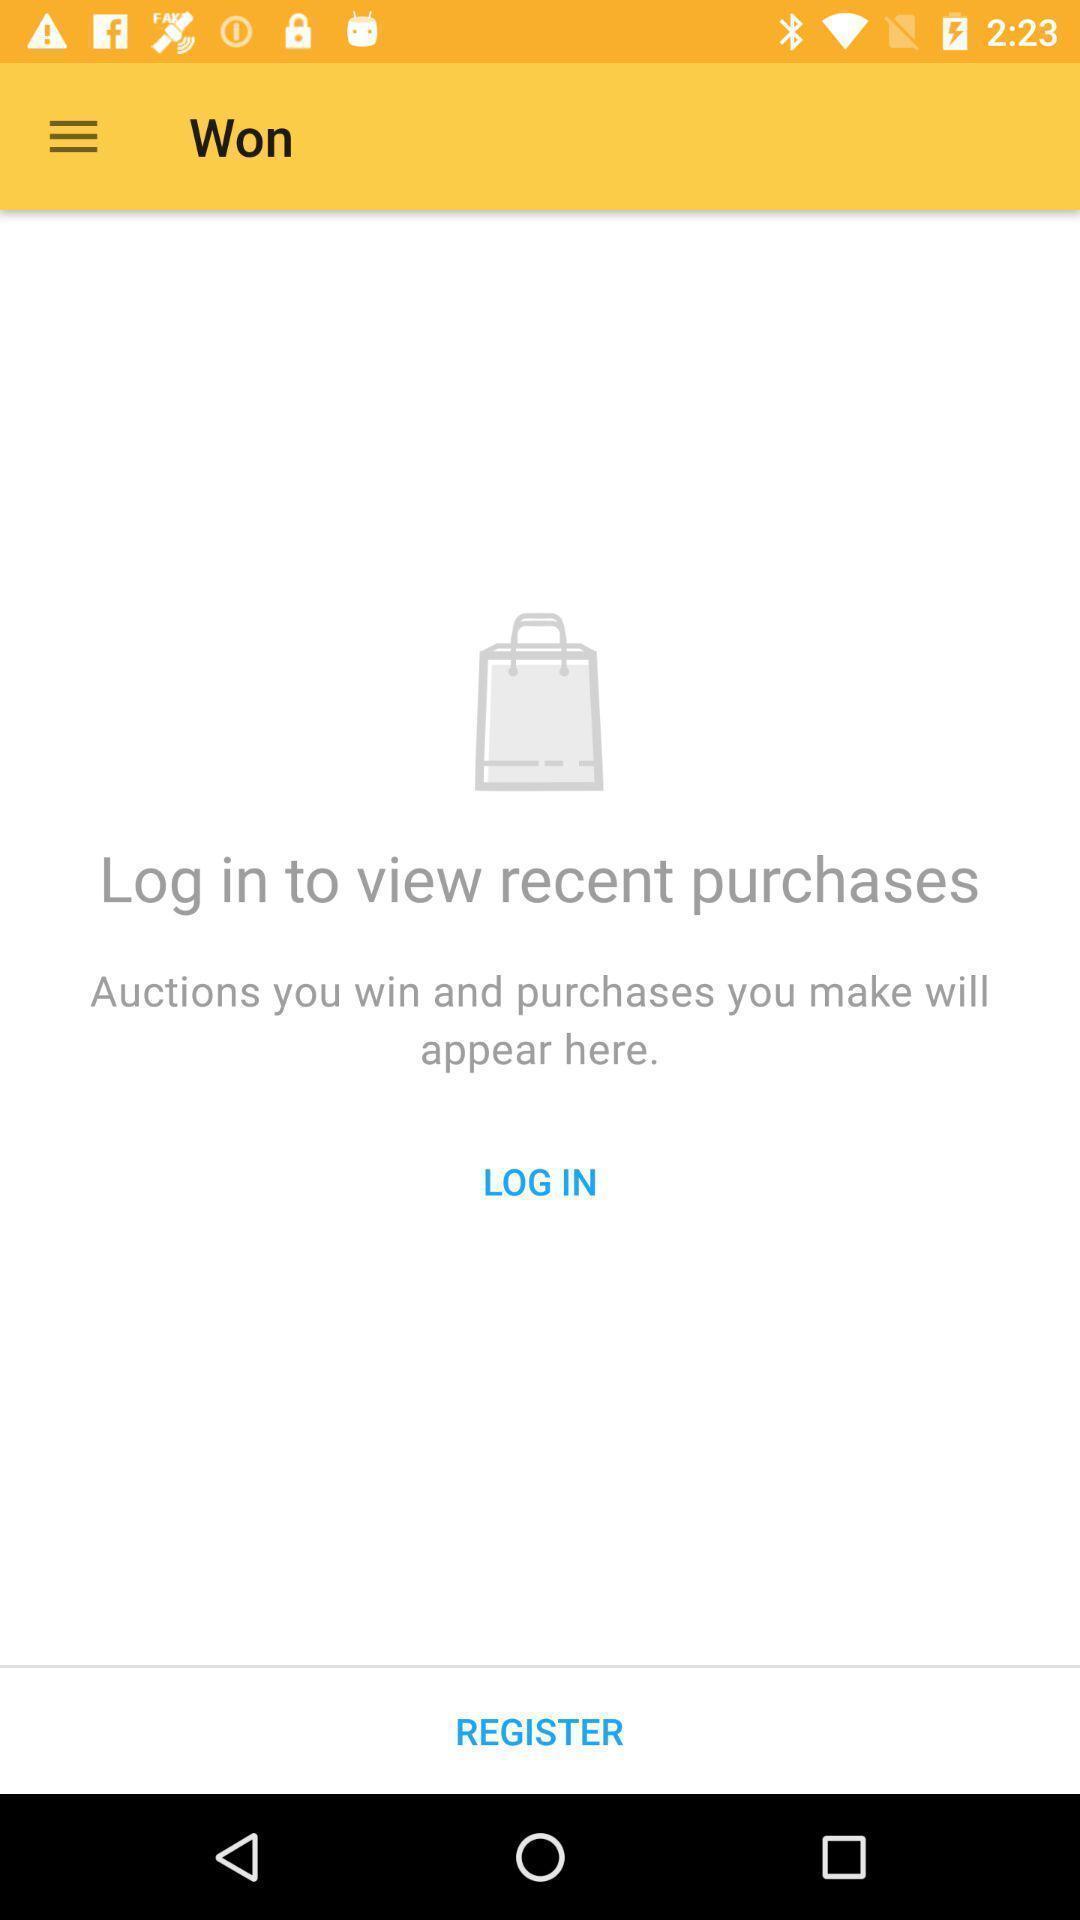Give me a narrative description of this picture. View recent purchases in shop. 